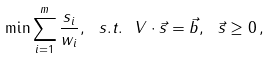Convert formula to latex. <formula><loc_0><loc_0><loc_500><loc_500>\min \sum _ { i = 1 } ^ { m } \frac { s _ { i } } { w _ { i } } , \ s . t . \ V \cdot \vec { s } = \vec { b } , \ \vec { s } \geq 0 \, ,</formula> 